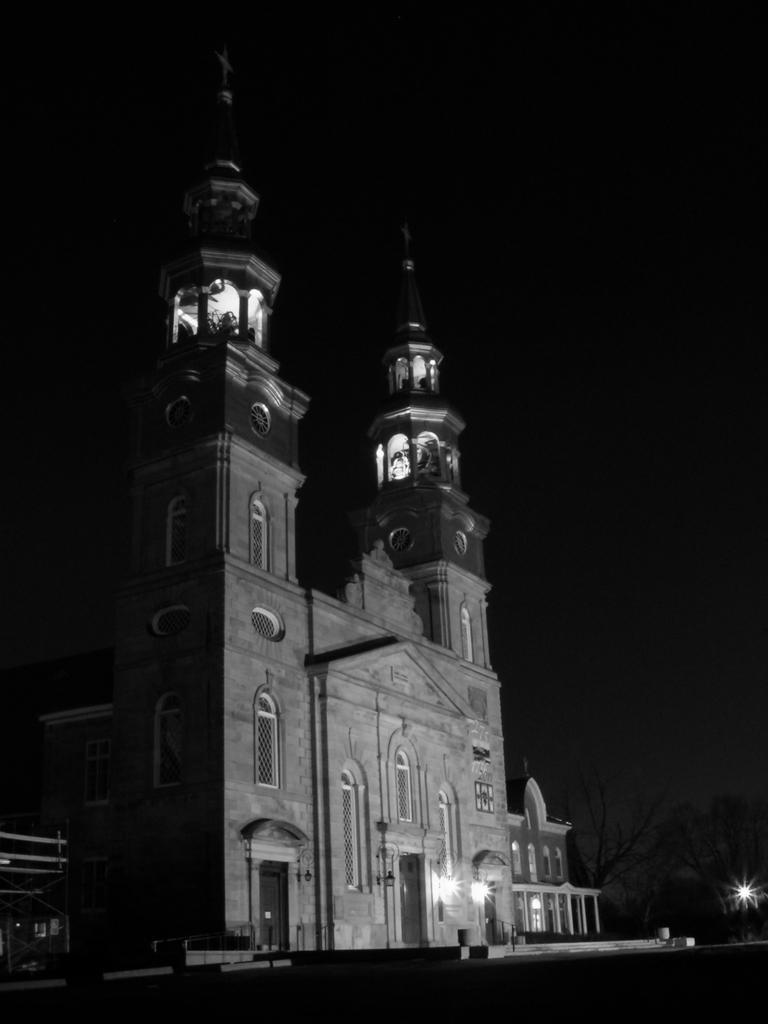In one or two sentences, can you explain what this image depicts? In the foreground I can see a building, lights and the sky. This image is taken may be during night. 